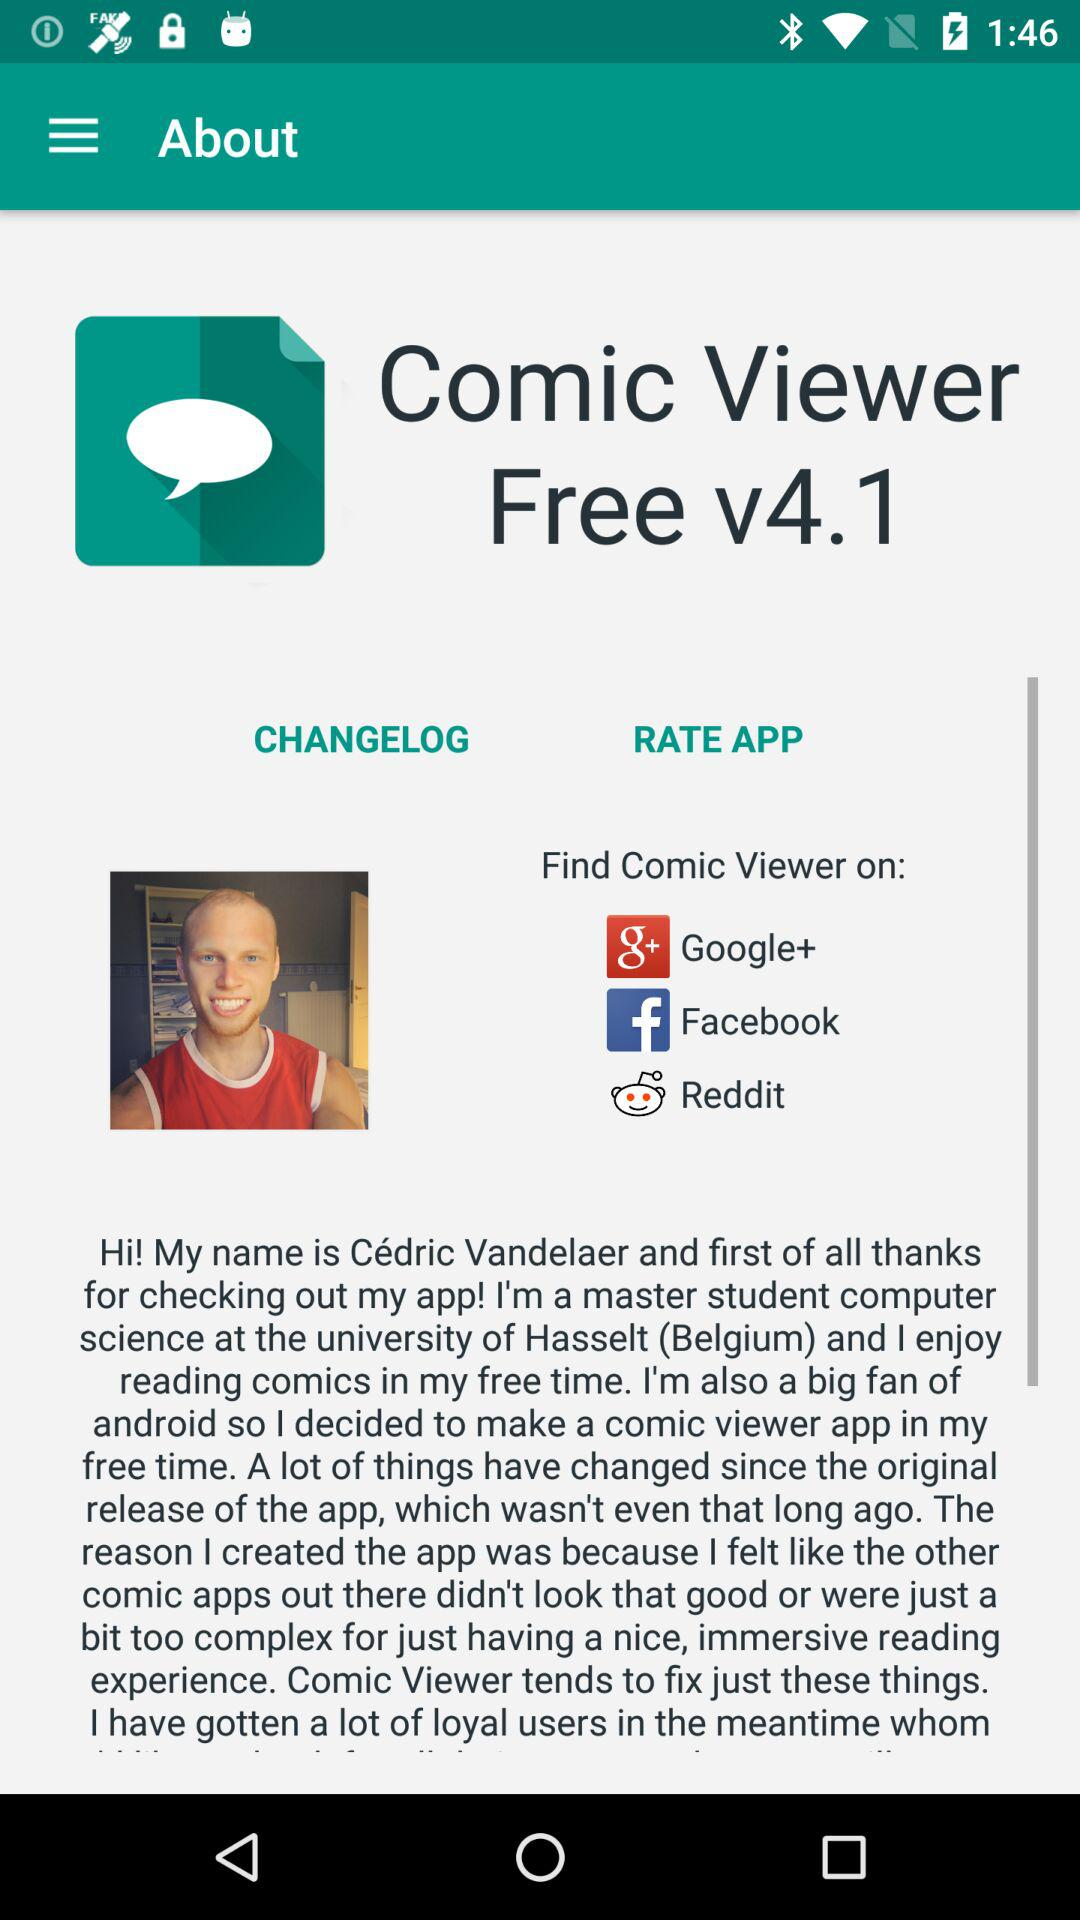What is the name of the application? The name of the application is "Comic Viewer Free v4.1". 